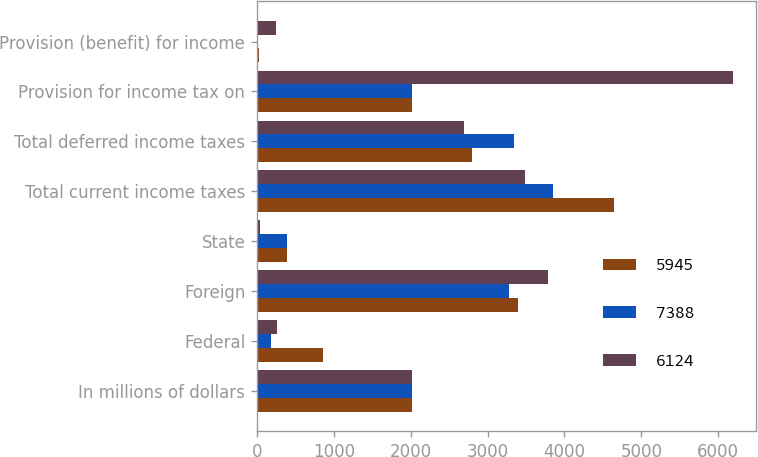<chart> <loc_0><loc_0><loc_500><loc_500><stacked_bar_chart><ecel><fcel>In millions of dollars<fcel>Federal<fcel>Foreign<fcel>State<fcel>Total current income taxes<fcel>Total deferred income taxes<fcel>Provision for income tax on<fcel>Provision (benefit) for income<nl><fcel>5945<fcel>2015<fcel>861<fcel>3397<fcel>388<fcel>4646<fcel>2794<fcel>2014.5<fcel>29<nl><fcel>7388<fcel>2014<fcel>181<fcel>3281<fcel>388<fcel>3850<fcel>3347<fcel>2014.5<fcel>12<nl><fcel>6124<fcel>2013<fcel>260<fcel>3788<fcel>41<fcel>3487<fcel>2699<fcel>6186<fcel>244<nl></chart> 